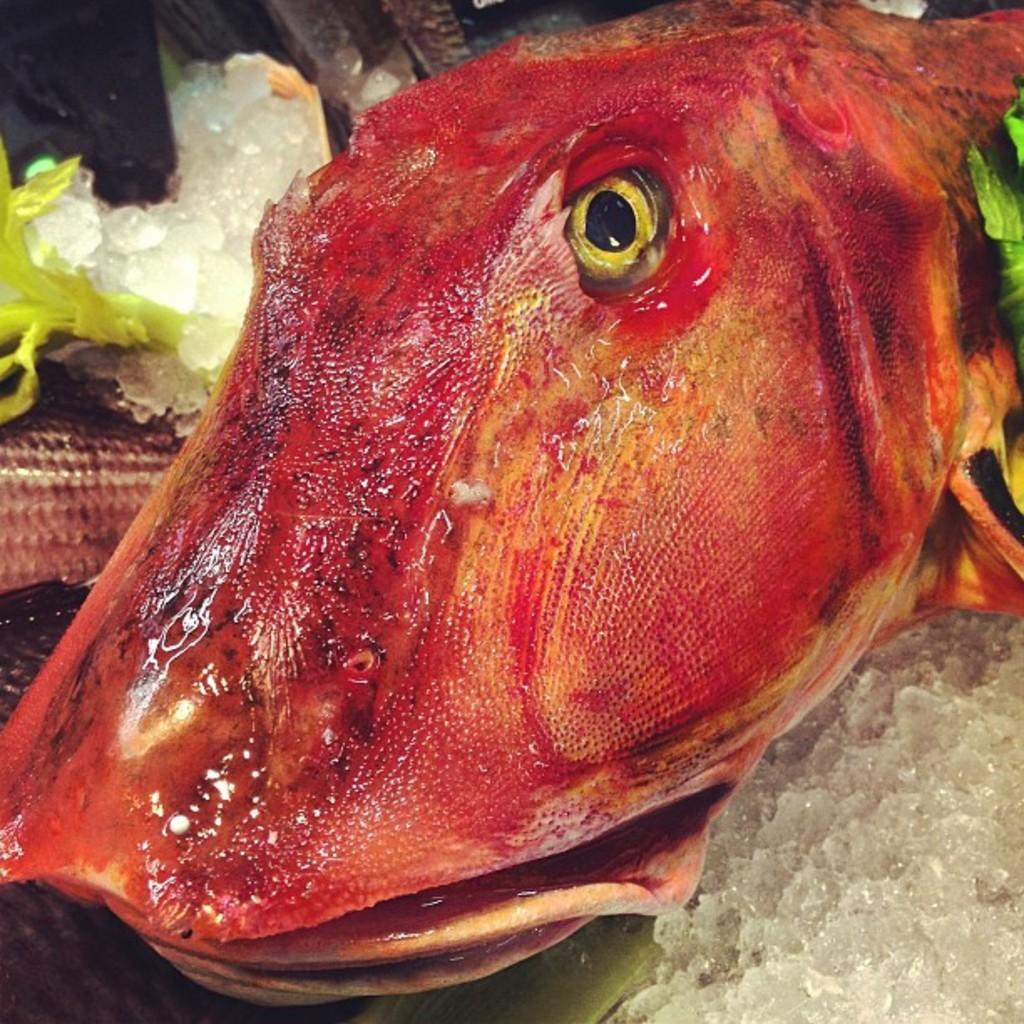What is the main subject of the image? The main subject of the image is a fish on the ice. Can you describe any other objects or elements in the image? Yes, there is a small plant on the left side of the image. Where is the fish located in relation to the plant? The fish is also on the ice on the left side of the image. What type of ring is the zebra wearing on its hoof in the image? There is no zebra or ring present in the image; it features a fish on the ice and a small plant. 